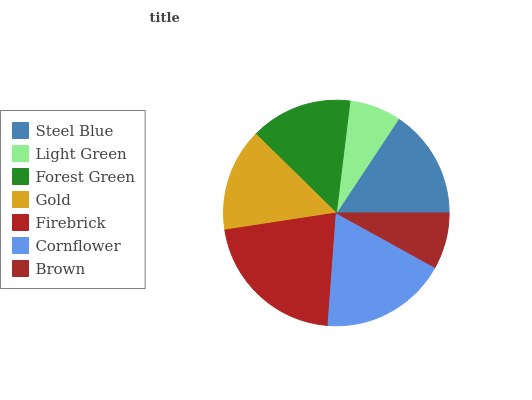Is Light Green the minimum?
Answer yes or no. Yes. Is Firebrick the maximum?
Answer yes or no. Yes. Is Forest Green the minimum?
Answer yes or no. No. Is Forest Green the maximum?
Answer yes or no. No. Is Forest Green greater than Light Green?
Answer yes or no. Yes. Is Light Green less than Forest Green?
Answer yes or no. Yes. Is Light Green greater than Forest Green?
Answer yes or no. No. Is Forest Green less than Light Green?
Answer yes or no. No. Is Gold the high median?
Answer yes or no. Yes. Is Gold the low median?
Answer yes or no. Yes. Is Forest Green the high median?
Answer yes or no. No. Is Forest Green the low median?
Answer yes or no. No. 